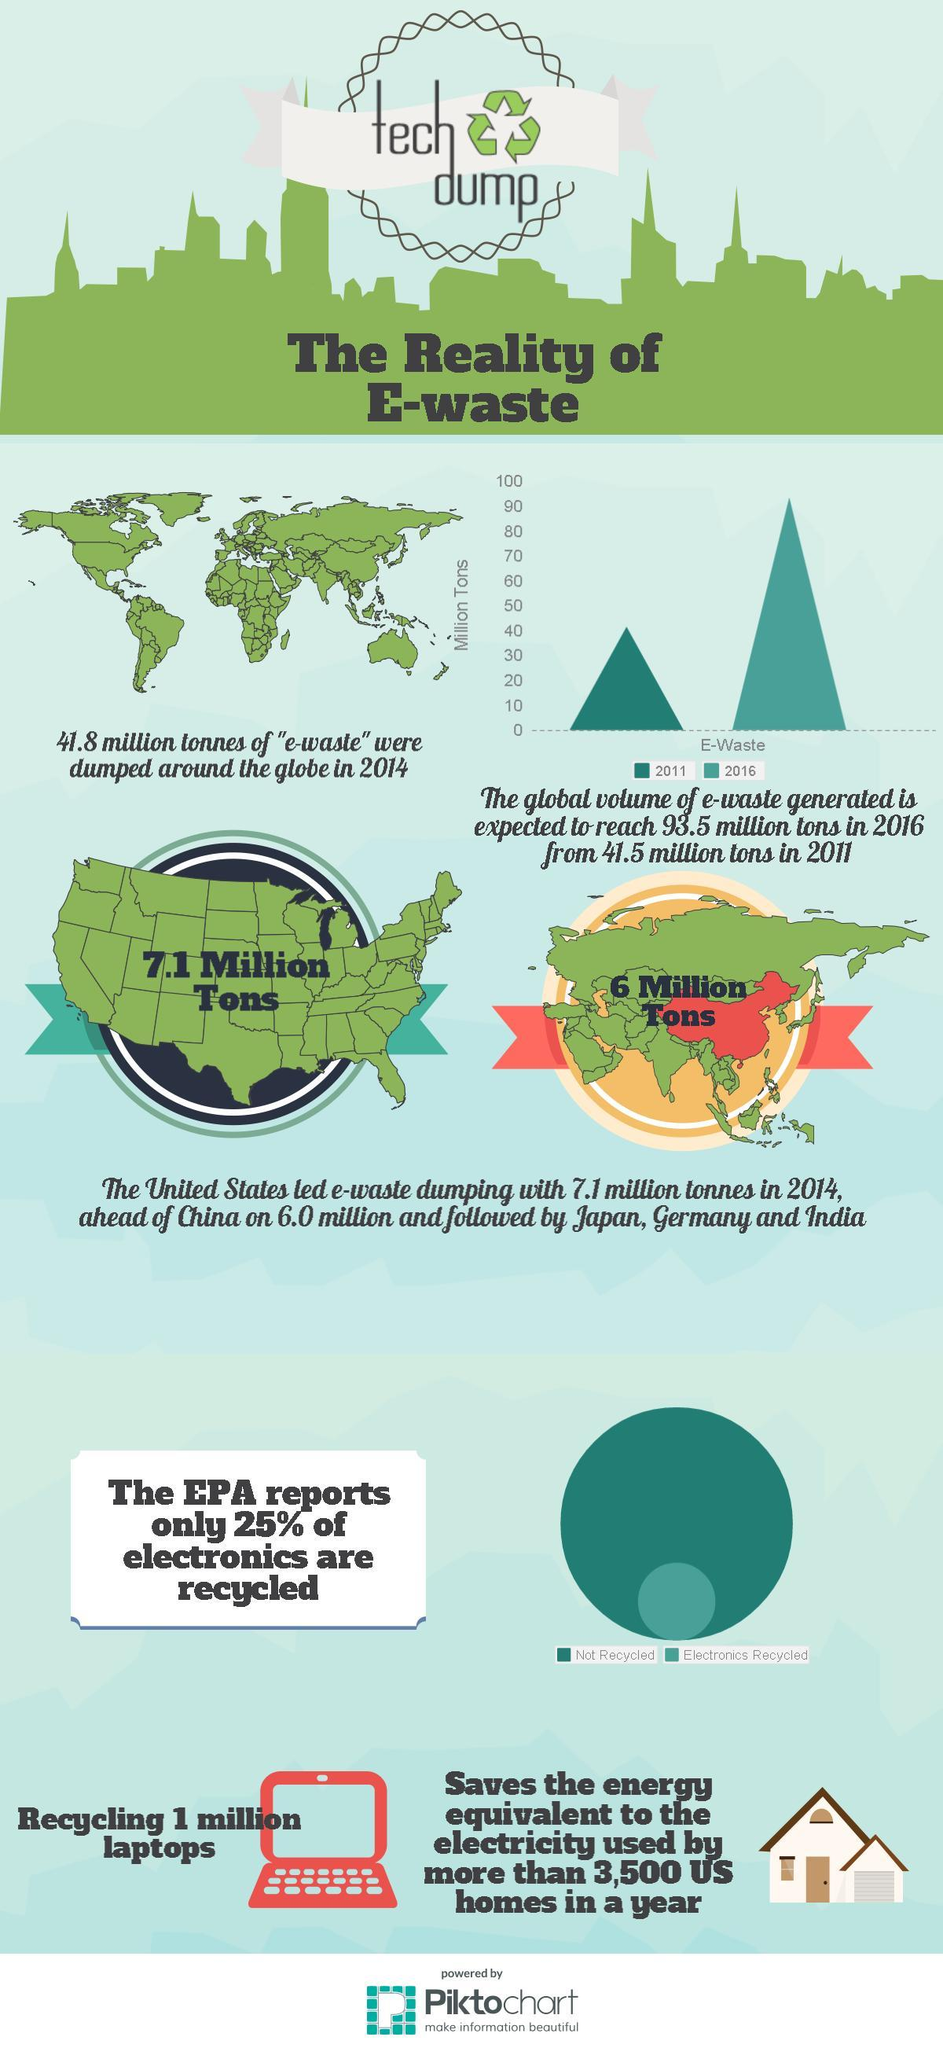How much is the increase in volume of e-wastage from 2011 to 2016 in million tonnes?
Answer the question with a short phrase. 52 How much is the global volume of e-wastage in million tons in 2016 ? 90 In which year quantity of e-wastage is the highest? 2016 According to EPA report what percentage of electronics are not recycled? 75 How much is the global volume of e-wastage in million tons in 2011 ? 40 